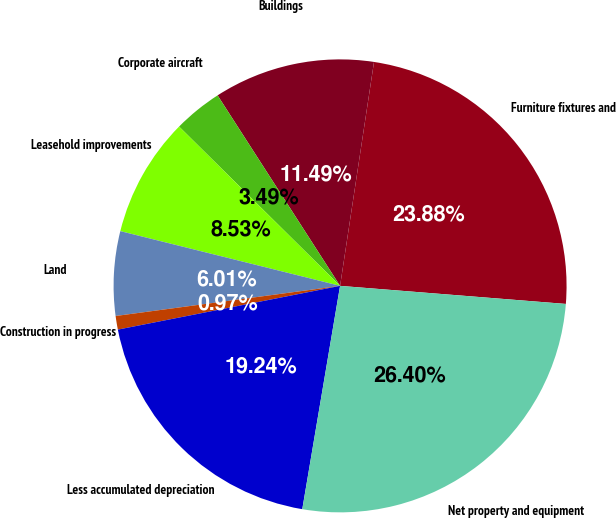Convert chart to OTSL. <chart><loc_0><loc_0><loc_500><loc_500><pie_chart><fcel>Furniture fixtures and<fcel>Buildings<fcel>Corporate aircraft<fcel>Leasehold improvements<fcel>Land<fcel>Construction in progress<fcel>Less accumulated depreciation<fcel>Net property and equipment<nl><fcel>23.88%<fcel>11.49%<fcel>3.49%<fcel>8.53%<fcel>6.01%<fcel>0.97%<fcel>19.24%<fcel>26.4%<nl></chart> 